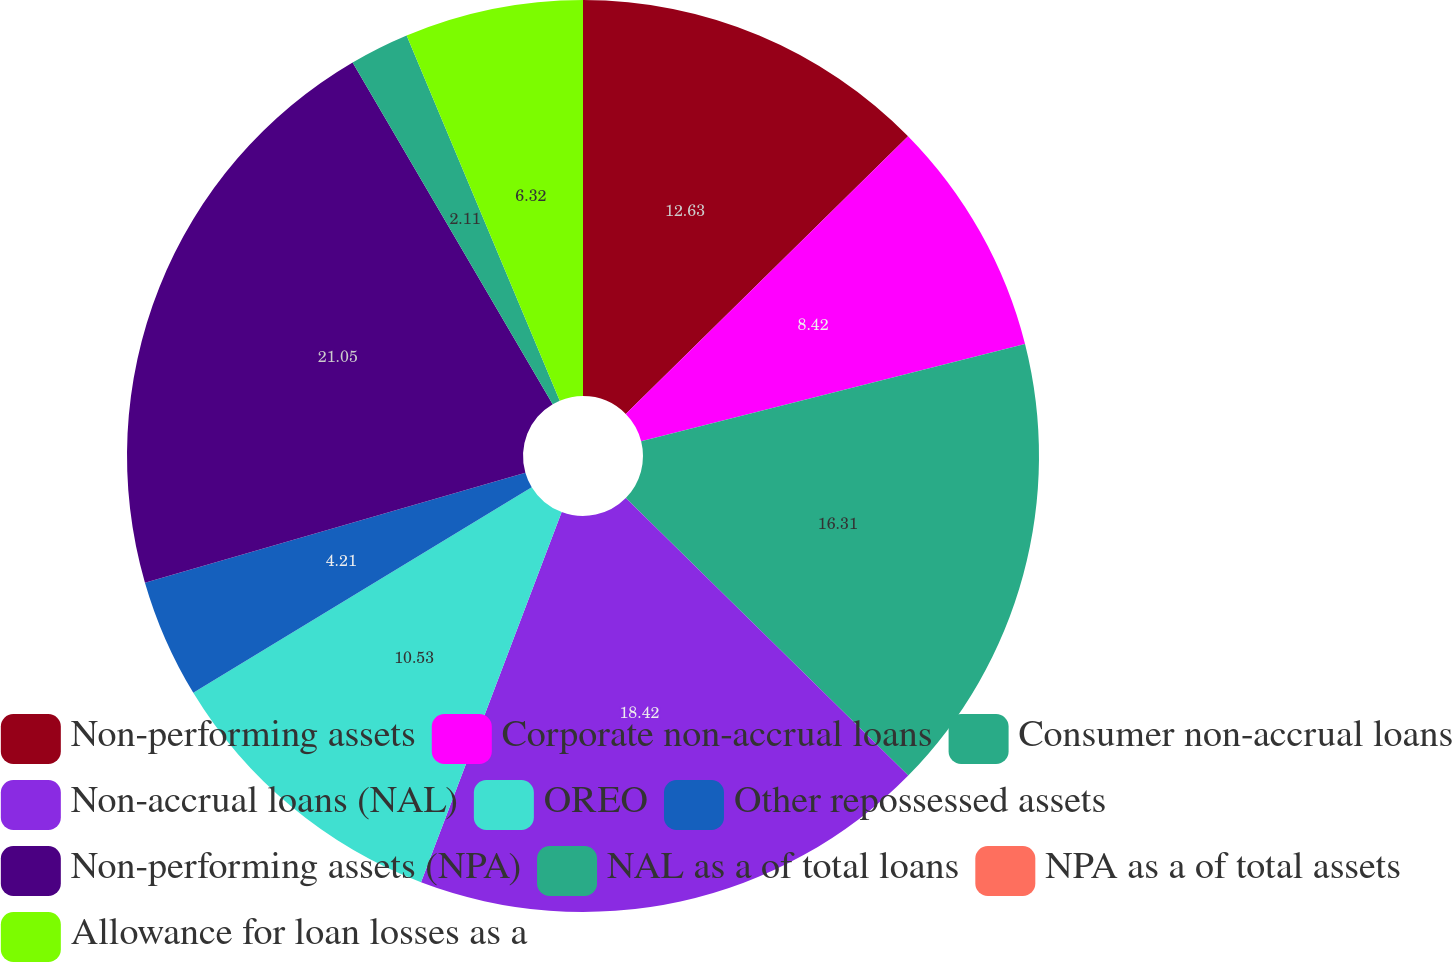Convert chart to OTSL. <chart><loc_0><loc_0><loc_500><loc_500><pie_chart><fcel>Non-performing assets<fcel>Corporate non-accrual loans<fcel>Consumer non-accrual loans<fcel>Non-accrual loans (NAL)<fcel>OREO<fcel>Other repossessed assets<fcel>Non-performing assets (NPA)<fcel>NAL as a of total loans<fcel>NPA as a of total assets<fcel>Allowance for loan losses as a<nl><fcel>12.63%<fcel>8.42%<fcel>16.31%<fcel>18.42%<fcel>10.53%<fcel>4.21%<fcel>21.05%<fcel>2.11%<fcel>0.0%<fcel>6.32%<nl></chart> 